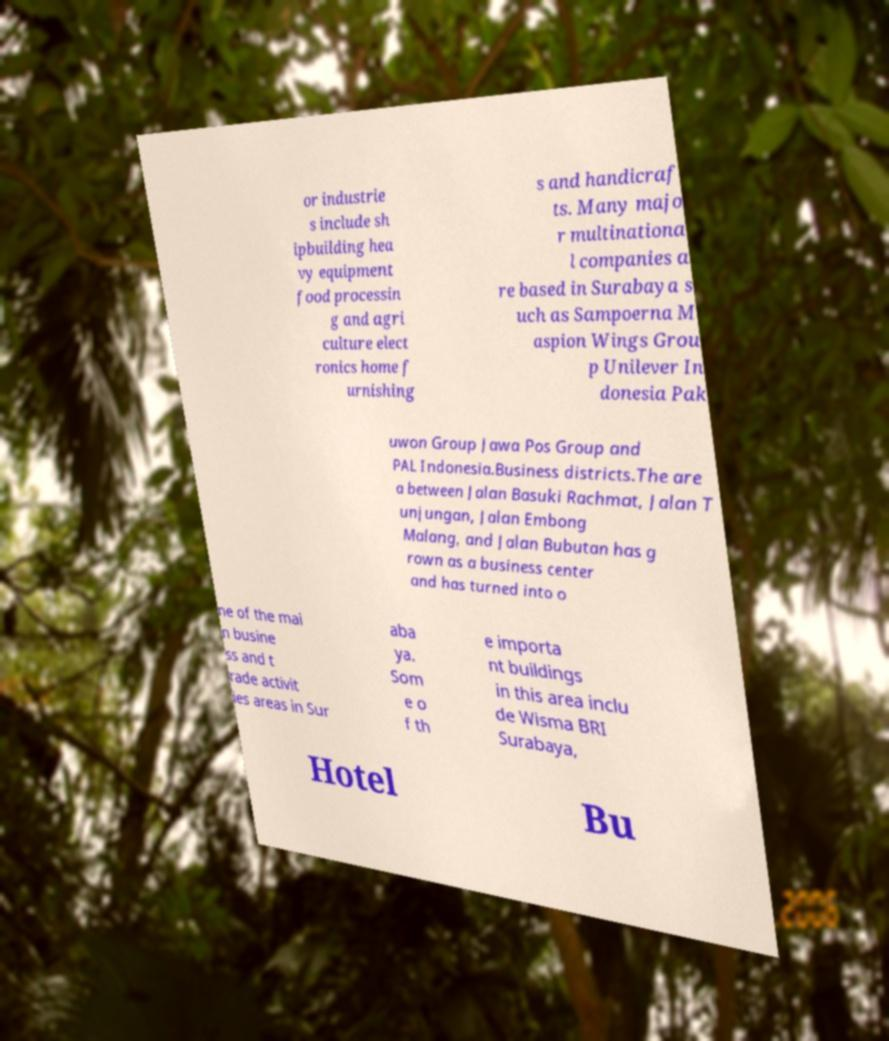Please identify and transcribe the text found in this image. or industrie s include sh ipbuilding hea vy equipment food processin g and agri culture elect ronics home f urnishing s and handicraf ts. Many majo r multinationa l companies a re based in Surabaya s uch as Sampoerna M aspion Wings Grou p Unilever In donesia Pak uwon Group Jawa Pos Group and PAL Indonesia.Business districts.The are a between Jalan Basuki Rachmat, Jalan T unjungan, Jalan Embong Malang, and Jalan Bubutan has g rown as a business center and has turned into o ne of the mai n busine ss and t rade activit ies areas in Sur aba ya. Som e o f th e importa nt buildings in this area inclu de Wisma BRI Surabaya, Hotel Bu 